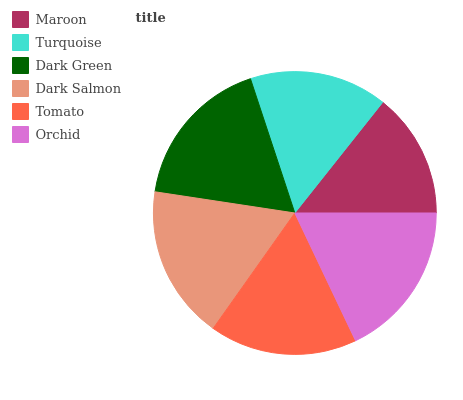Is Maroon the minimum?
Answer yes or no. Yes. Is Orchid the maximum?
Answer yes or no. Yes. Is Turquoise the minimum?
Answer yes or no. No. Is Turquoise the maximum?
Answer yes or no. No. Is Turquoise greater than Maroon?
Answer yes or no. Yes. Is Maroon less than Turquoise?
Answer yes or no. Yes. Is Maroon greater than Turquoise?
Answer yes or no. No. Is Turquoise less than Maroon?
Answer yes or no. No. Is Dark Green the high median?
Answer yes or no. Yes. Is Tomato the low median?
Answer yes or no. Yes. Is Tomato the high median?
Answer yes or no. No. Is Maroon the low median?
Answer yes or no. No. 